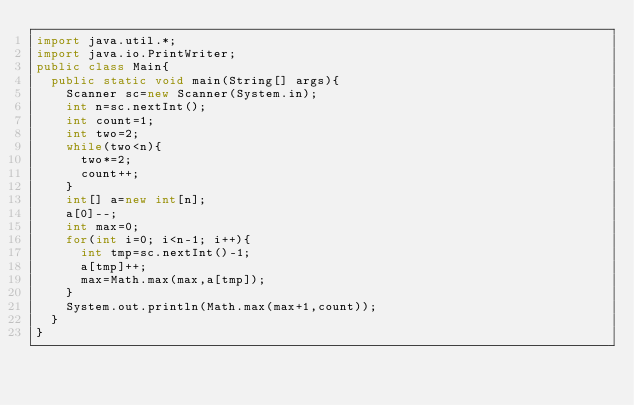Convert code to text. <code><loc_0><loc_0><loc_500><loc_500><_Java_>import java.util.*;
import java.io.PrintWriter;
public class Main{
	public static void main(String[] args){
		Scanner sc=new Scanner(System.in);
		int n=sc.nextInt();
		int count=1;
		int two=2;
		while(two<n){
			two*=2;
			count++;
		}
		int[] a=new int[n];
		a[0]--;
		int max=0;
		for(int i=0; i<n-1; i++){
			int tmp=sc.nextInt()-1;
			a[tmp]++;
			max=Math.max(max,a[tmp]);
		}
		System.out.println(Math.max(max+1,count));
	}
}
</code> 